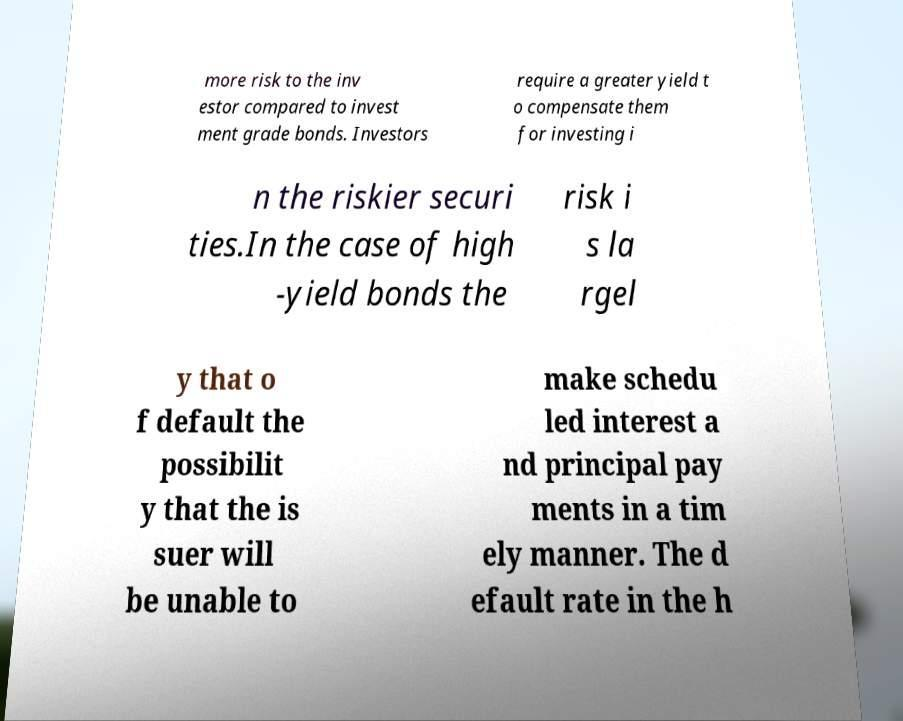What messages or text are displayed in this image? I need them in a readable, typed format. more risk to the inv estor compared to invest ment grade bonds. Investors require a greater yield t o compensate them for investing i n the riskier securi ties.In the case of high -yield bonds the risk i s la rgel y that o f default the possibilit y that the is suer will be unable to make schedu led interest a nd principal pay ments in a tim ely manner. The d efault rate in the h 